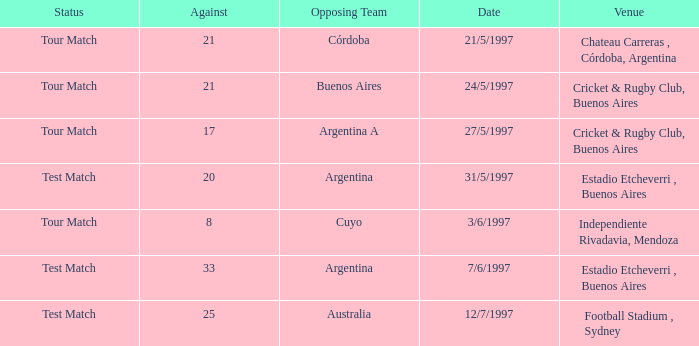What was the average of againsts on 21/5/1997? 21.0. 